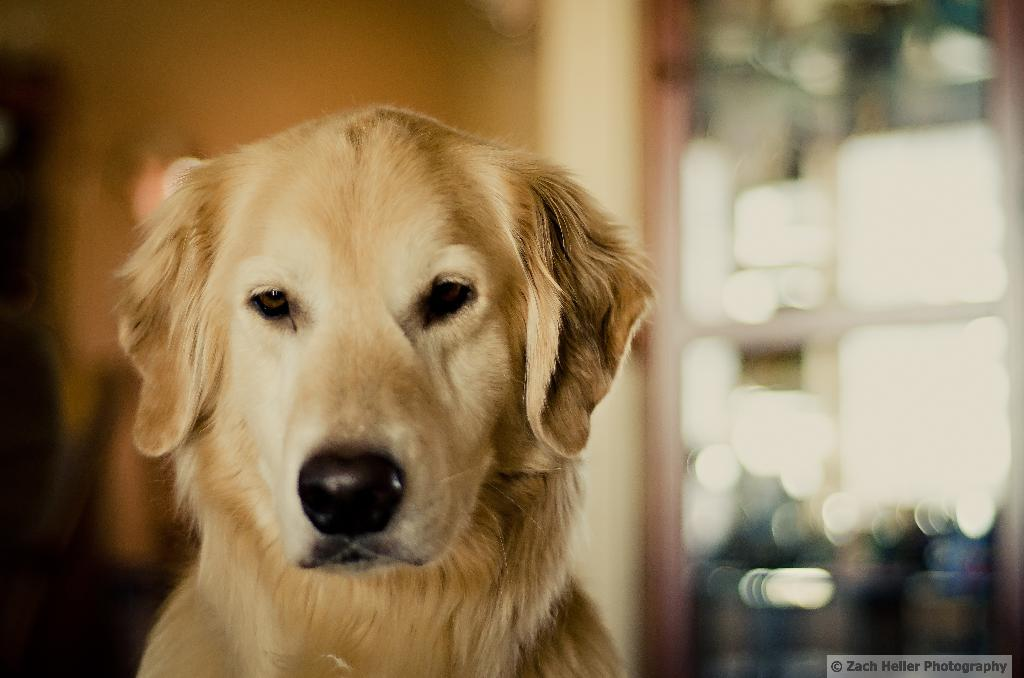What type of animal is in the image? There is a dog in the image. What is located on the right side of the image? There is a glass door on the right side of the image. What color is the background of the image? The background of the image is brown in color. How is the background of the image depicted? The background of the image is blurred. What type of apple can be seen in the image? There is no apple present in the image. What type of cast is visible on the dog's leg in the image? There is no cast visible on the dog's leg in the image. 